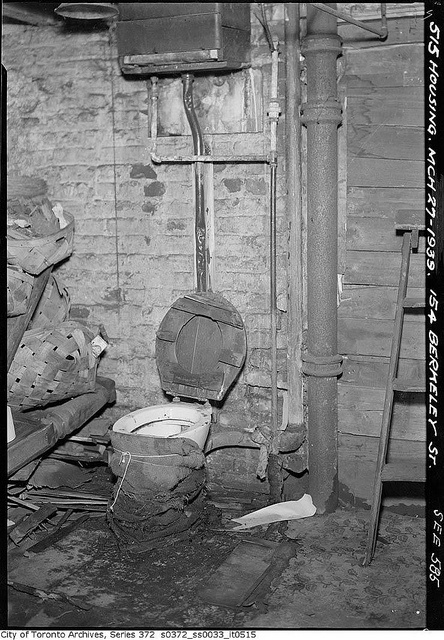Describe the objects in this image and their specific colors. I can see toilet in black, gray, darkgray, and lightgray tones and toilet in black, gray, and lightgray tones in this image. 